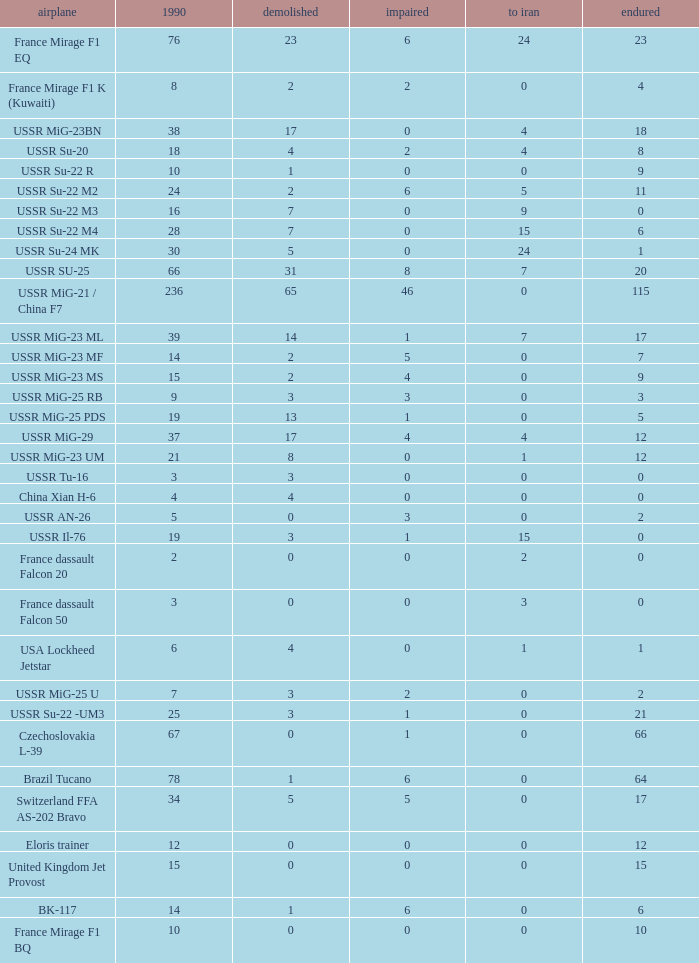0, what was the total in 1990? 1.0. 